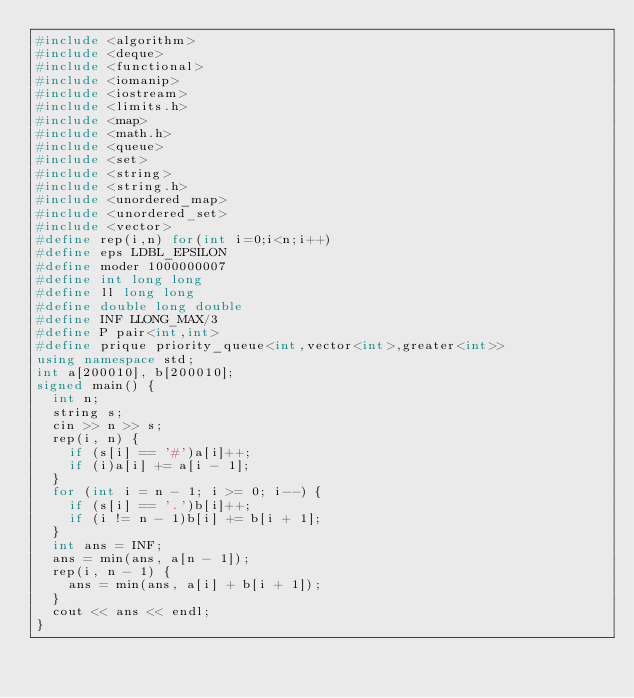Convert code to text. <code><loc_0><loc_0><loc_500><loc_500><_C++_>#include <algorithm>
#include <deque>
#include <functional>
#include <iomanip>
#include <iostream>
#include <limits.h>
#include <map>
#include <math.h>
#include <queue>
#include <set>
#include <string>
#include <string.h>
#include <unordered_map>
#include <unordered_set>
#include <vector>
#define rep(i,n) for(int i=0;i<n;i++)
#define eps LDBL_EPSILON
#define moder 1000000007
#define int long long
#define ll long long
#define double long double
#define INF LLONG_MAX/3
#define P pair<int,int>
#define prique priority_queue<int,vector<int>,greater<int>>
using namespace std;
int a[200010], b[200010];
signed main() {
	int n;
	string s;
	cin >> n >> s;
	rep(i, n) {
		if (s[i] == '#')a[i]++;
		if (i)a[i] += a[i - 1];
	}
	for (int i = n - 1; i >= 0; i--) {
		if (s[i] == '.')b[i]++;
		if (i != n - 1)b[i] += b[i + 1];
	}
	int ans = INF;
	ans = min(ans, a[n - 1]);
	rep(i, n - 1) {
		ans = min(ans, a[i] + b[i + 1]);
	}
	cout << ans << endl;
}</code> 